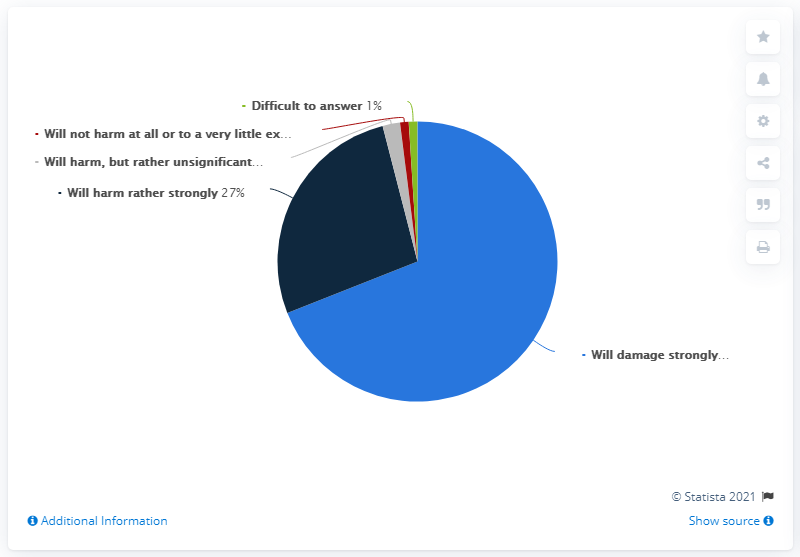Outline some significant characteristics in this image. The category that occupied more than half of the pie chart is likely to have a strong negative impact if it is damaged. The result of adding dark blue and green colors is 28. 